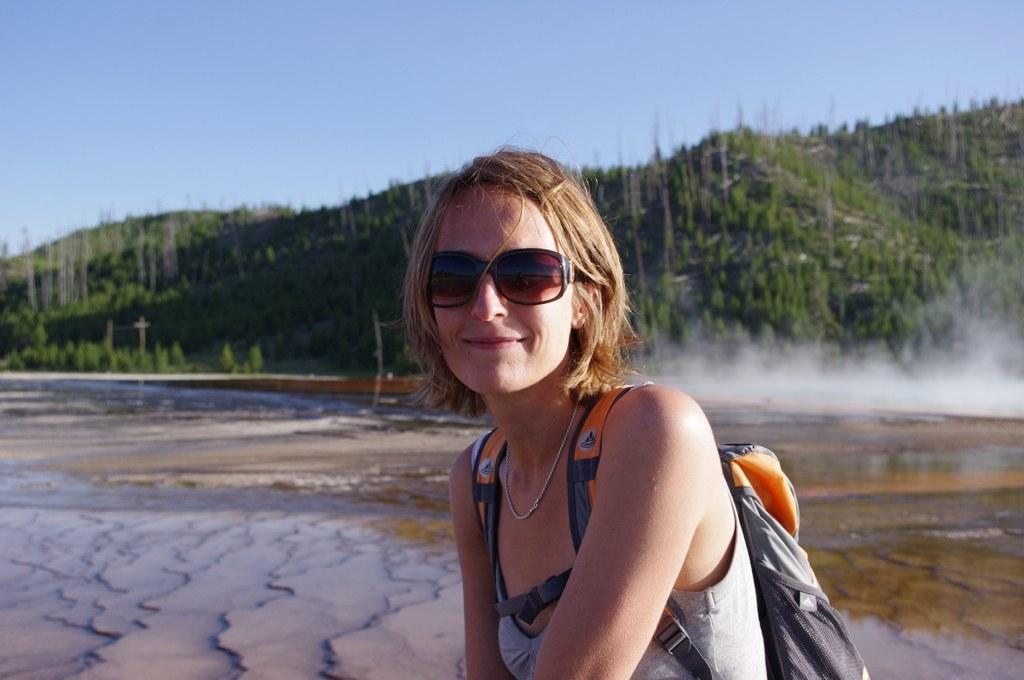Who is present in the image? There is a woman in the image. What is the woman's facial expression? The woman is smiling. What accessories is the woman wearing? The woman is wearing a bag and goggles. What is the setting of the image? There is water visible in the image, along with trees, poles, and the sky. What else can be seen in the image? There is smoke in the image. What type of note is the woman holding in the image? There is no note visible in the image; the woman is wearing goggles and a bag. What kind of jelly can be seen in the image? There is no jelly present in the image. 